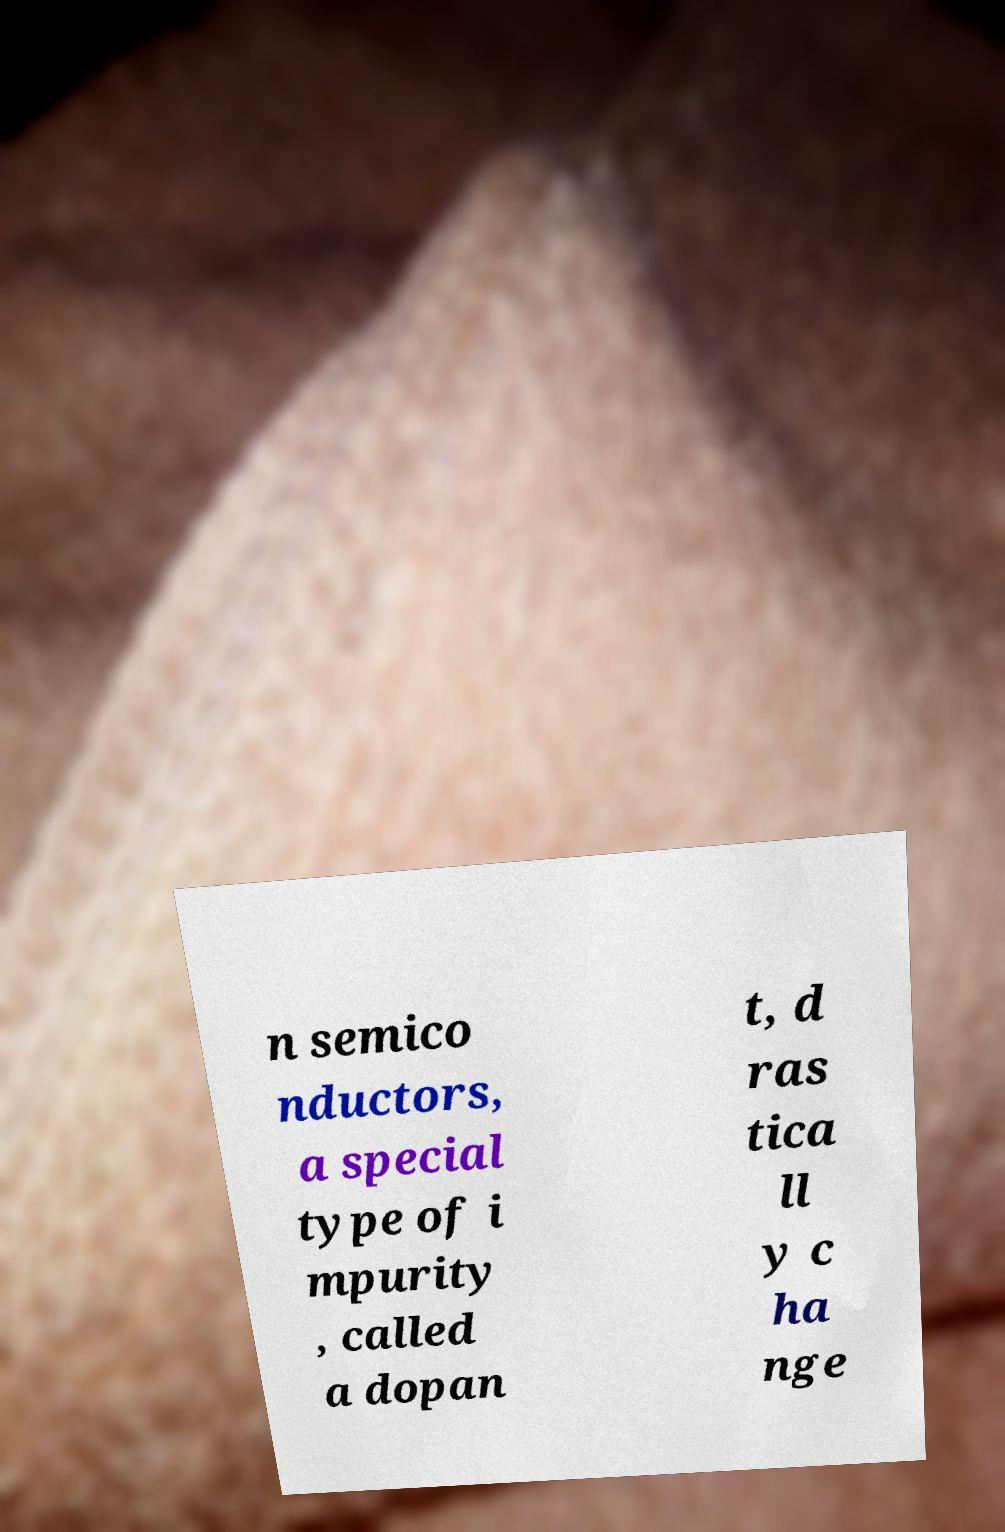Can you accurately transcribe the text from the provided image for me? n semico nductors, a special type of i mpurity , called a dopan t, d ras tica ll y c ha nge 